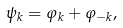<formula> <loc_0><loc_0><loc_500><loc_500>\psi _ { k } = \varphi _ { k } + \varphi _ { - k } ,</formula> 